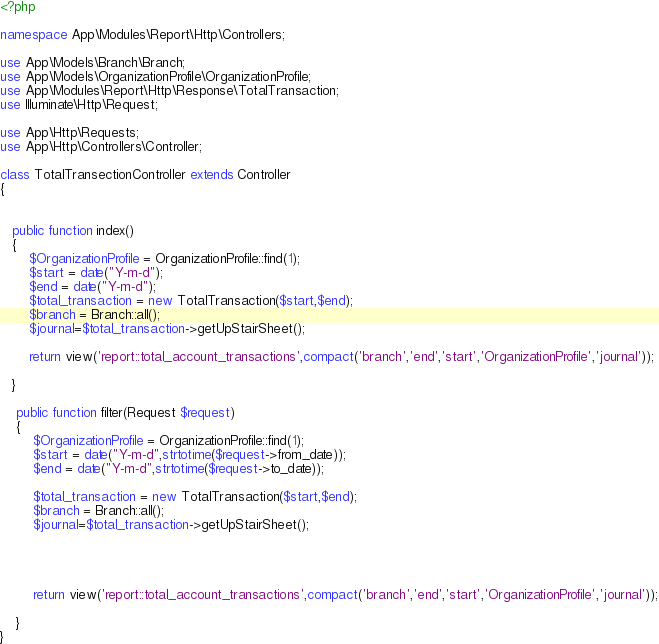<code> <loc_0><loc_0><loc_500><loc_500><_PHP_><?php

namespace App\Modules\Report\Http\Controllers;

use App\Models\Branch\Branch;
use App\Models\OrganizationProfile\OrganizationProfile;
use App\Modules\Report\Http\Response\TotalTransaction;
use Illuminate\Http\Request;

use App\Http\Requests;
use App\Http\Controllers\Controller;

class TotalTransectionController extends Controller
{


   public function index()
   {
       $OrganizationProfile = OrganizationProfile::find(1);
       $start = date("Y-m-d");
       $end = date("Y-m-d");
       $total_transaction = new TotalTransaction($start,$end);
       $branch = Branch::all();
       $journal=$total_transaction->getUpStairSheet();

       return view('report::total_account_transactions',compact('branch','end','start','OrganizationProfile','journal'));

   }

    public function filter(Request $request)
    {
        $OrganizationProfile = OrganizationProfile::find(1);
        $start = date("Y-m-d",strtotime($request->from_date));
        $end = date("Y-m-d",strtotime($request->to_date));

        $total_transaction = new TotalTransaction($start,$end);
        $branch = Branch::all();
        $journal=$total_transaction->getUpStairSheet();




        return view('report::total_account_transactions',compact('branch','end','start','OrganizationProfile','journal'));

    }
}
</code> 